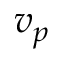<formula> <loc_0><loc_0><loc_500><loc_500>v _ { p }</formula> 